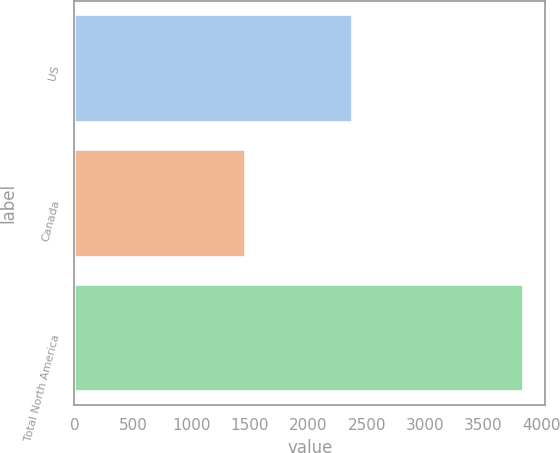<chart> <loc_0><loc_0><loc_500><loc_500><bar_chart><fcel>US<fcel>Canada<fcel>Total North America<nl><fcel>2372<fcel>1462<fcel>3834<nl></chart> 